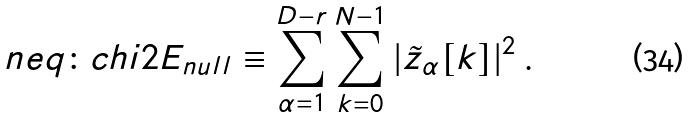<formula> <loc_0><loc_0><loc_500><loc_500>\ n { e q \colon c h i 2 } E _ { n u l l } \equiv \sum _ { \alpha = 1 } ^ { D - r } \sum _ { k = 0 } ^ { N - 1 } | \tilde { z } _ { \alpha } [ k ] | ^ { 2 } \, .</formula> 